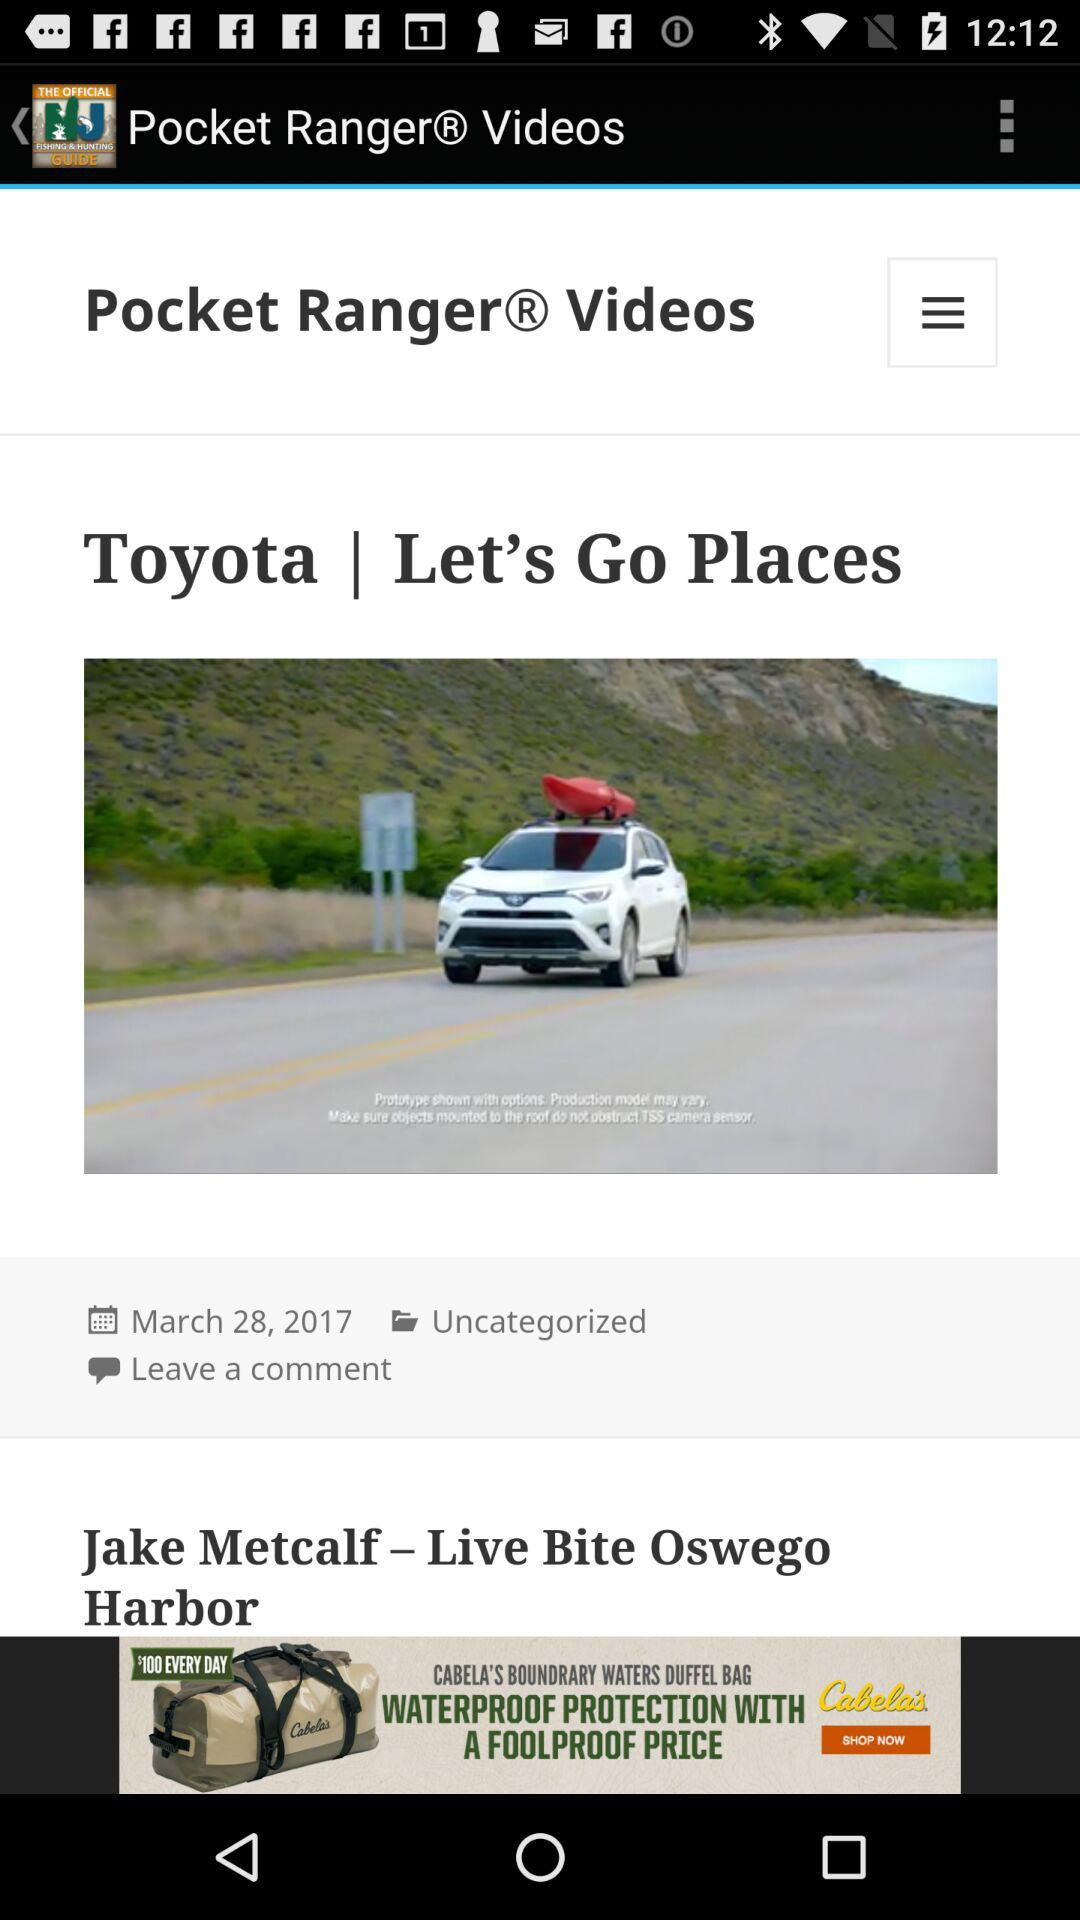When was "Toyota Let's Go Places" published? "Toyota Let's Go Places" was published on March 28, 2017. 